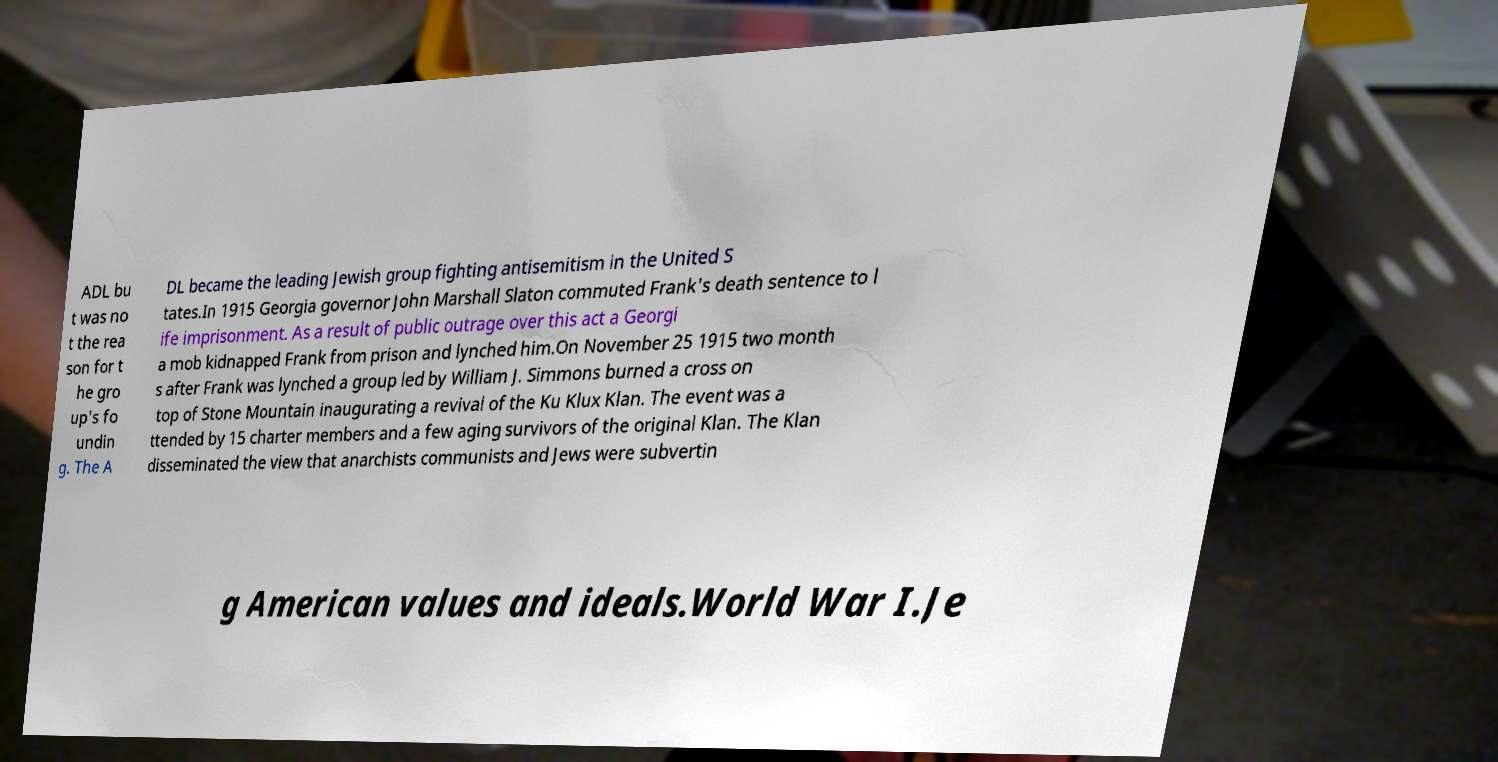Can you read and provide the text displayed in the image?This photo seems to have some interesting text. Can you extract and type it out for me? ADL bu t was no t the rea son for t he gro up's fo undin g. The A DL became the leading Jewish group fighting antisemitism in the United S tates.In 1915 Georgia governor John Marshall Slaton commuted Frank's death sentence to l ife imprisonment. As a result of public outrage over this act a Georgi a mob kidnapped Frank from prison and lynched him.On November 25 1915 two month s after Frank was lynched a group led by William J. Simmons burned a cross on top of Stone Mountain inaugurating a revival of the Ku Klux Klan. The event was a ttended by 15 charter members and a few aging survivors of the original Klan. The Klan disseminated the view that anarchists communists and Jews were subvertin g American values and ideals.World War I.Je 